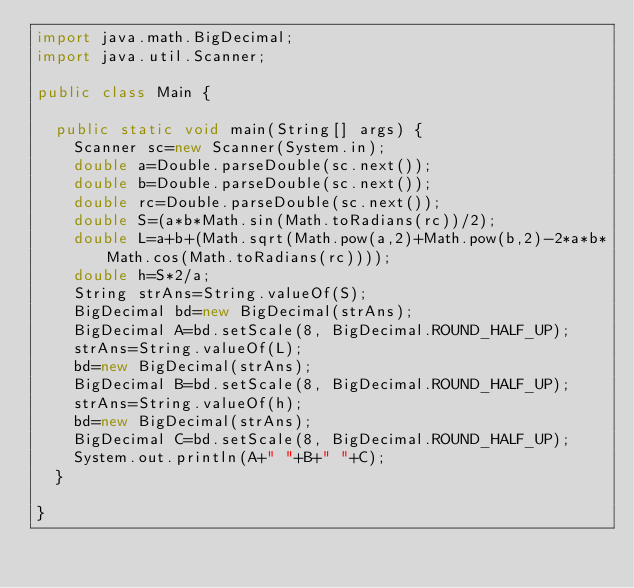<code> <loc_0><loc_0><loc_500><loc_500><_Java_>import java.math.BigDecimal;
import java.util.Scanner;

public class Main {

	public static void main(String[] args) {
		Scanner sc=new Scanner(System.in);
		double a=Double.parseDouble(sc.next());
		double b=Double.parseDouble(sc.next());
		double rc=Double.parseDouble(sc.next());
		double S=(a*b*Math.sin(Math.toRadians(rc))/2);
		double L=a+b+(Math.sqrt(Math.pow(a,2)+Math.pow(b,2)-2*a*b*Math.cos(Math.toRadians(rc))));
		double h=S*2/a;
		String strAns=String.valueOf(S);
		BigDecimal bd=new BigDecimal(strAns);
		BigDecimal A=bd.setScale(8, BigDecimal.ROUND_HALF_UP);
		strAns=String.valueOf(L);
		bd=new BigDecimal(strAns);
		BigDecimal B=bd.setScale(8, BigDecimal.ROUND_HALF_UP);
		strAns=String.valueOf(h);
		bd=new BigDecimal(strAns);
		BigDecimal C=bd.setScale(8, BigDecimal.ROUND_HALF_UP);
		System.out.println(A+" "+B+" "+C);
	}

}

</code> 